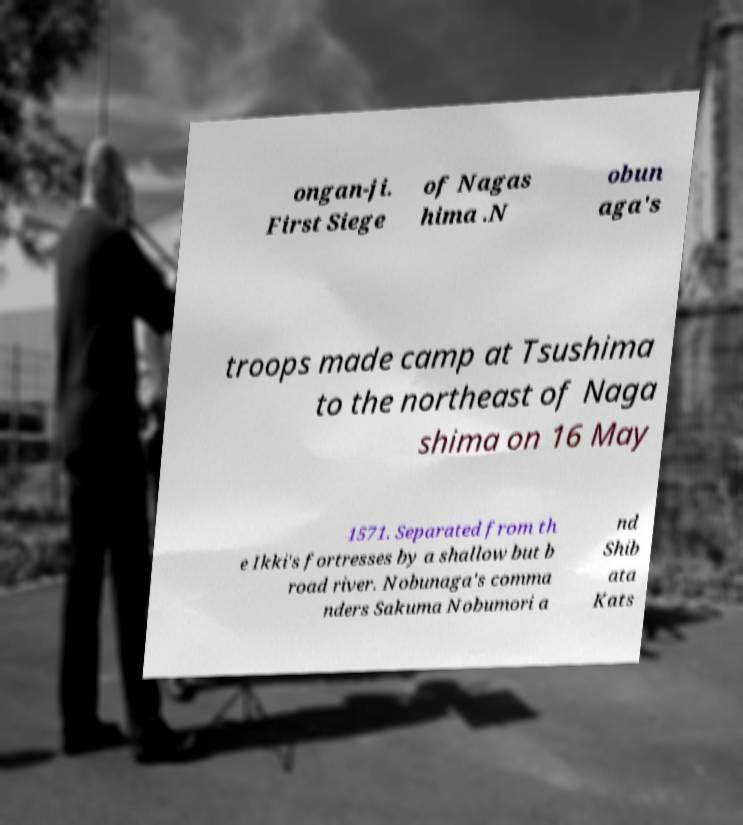What messages or text are displayed in this image? I need them in a readable, typed format. ongan-ji. First Siege of Nagas hima .N obun aga's troops made camp at Tsushima to the northeast of Naga shima on 16 May 1571. Separated from th e Ikki's fortresses by a shallow but b road river. Nobunaga's comma nders Sakuma Nobumori a nd Shib ata Kats 